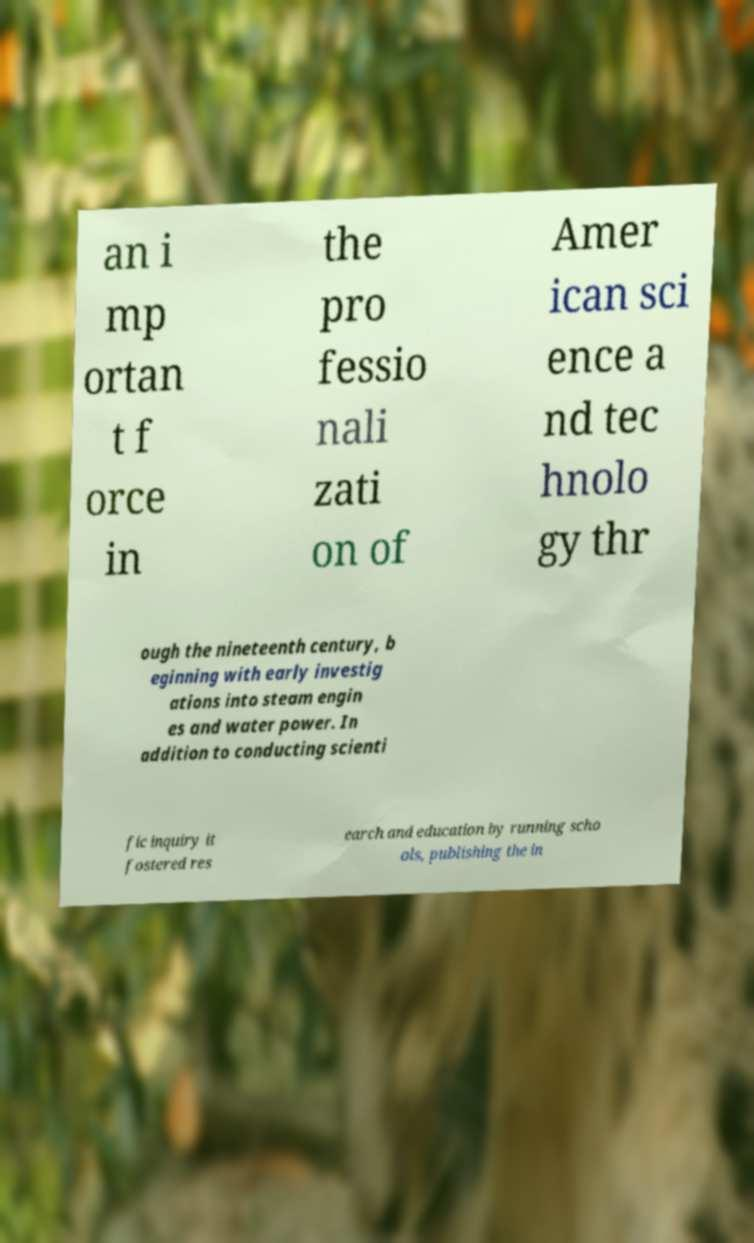Please read and relay the text visible in this image. What does it say? an i mp ortan t f orce in the pro fessio nali zati on of Amer ican sci ence a nd tec hnolo gy thr ough the nineteenth century, b eginning with early investig ations into steam engin es and water power. In addition to conducting scienti fic inquiry it fostered res earch and education by running scho ols, publishing the in 